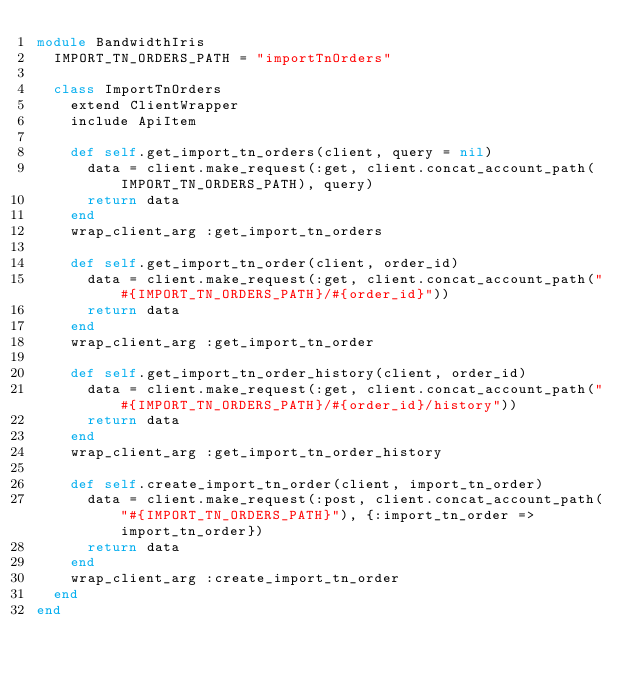<code> <loc_0><loc_0><loc_500><loc_500><_Ruby_>module BandwidthIris
  IMPORT_TN_ORDERS_PATH = "importTnOrders"

  class ImportTnOrders
    extend ClientWrapper
    include ApiItem

    def self.get_import_tn_orders(client, query = nil)
      data = client.make_request(:get, client.concat_account_path(IMPORT_TN_ORDERS_PATH), query)
      return data
    end
    wrap_client_arg :get_import_tn_orders

    def self.get_import_tn_order(client, order_id)
      data = client.make_request(:get, client.concat_account_path("#{IMPORT_TN_ORDERS_PATH}/#{order_id}"))
      return data
    end
    wrap_client_arg :get_import_tn_order

    def self.get_import_tn_order_history(client, order_id)
      data = client.make_request(:get, client.concat_account_path("#{IMPORT_TN_ORDERS_PATH}/#{order_id}/history"))
      return data
    end
    wrap_client_arg :get_import_tn_order_history

    def self.create_import_tn_order(client, import_tn_order)
      data = client.make_request(:post, client.concat_account_path("#{IMPORT_TN_ORDERS_PATH}"), {:import_tn_order => import_tn_order})
      return data
    end
    wrap_client_arg :create_import_tn_order
  end
end
</code> 